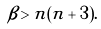Convert formula to latex. <formula><loc_0><loc_0><loc_500><loc_500>\beta > n ( n + 3 ) .</formula> 